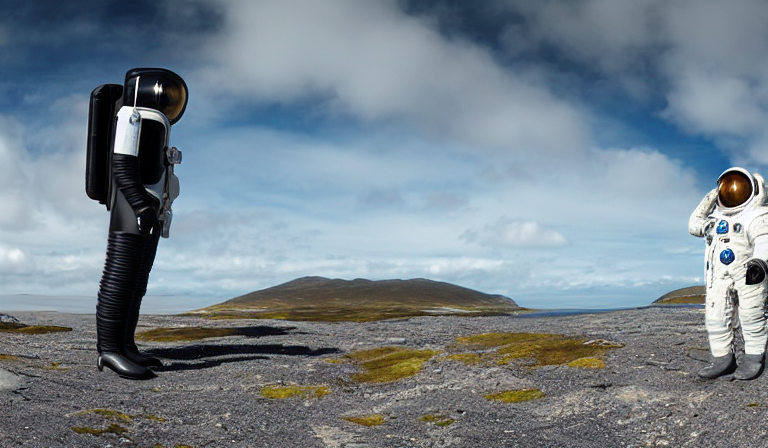How does the landscape contribute to the overall mood of the image? The barren landscape with its muted colors and lack of vegetation creates a desolate and tranquil setting. It complements the surreal characters by providing a sparse backdrop that feels both spacious and isolated. This setting amplifies the impact of the subjects in the foreground and underscores themes of solitude and the stark beauty of uncharted territories. 